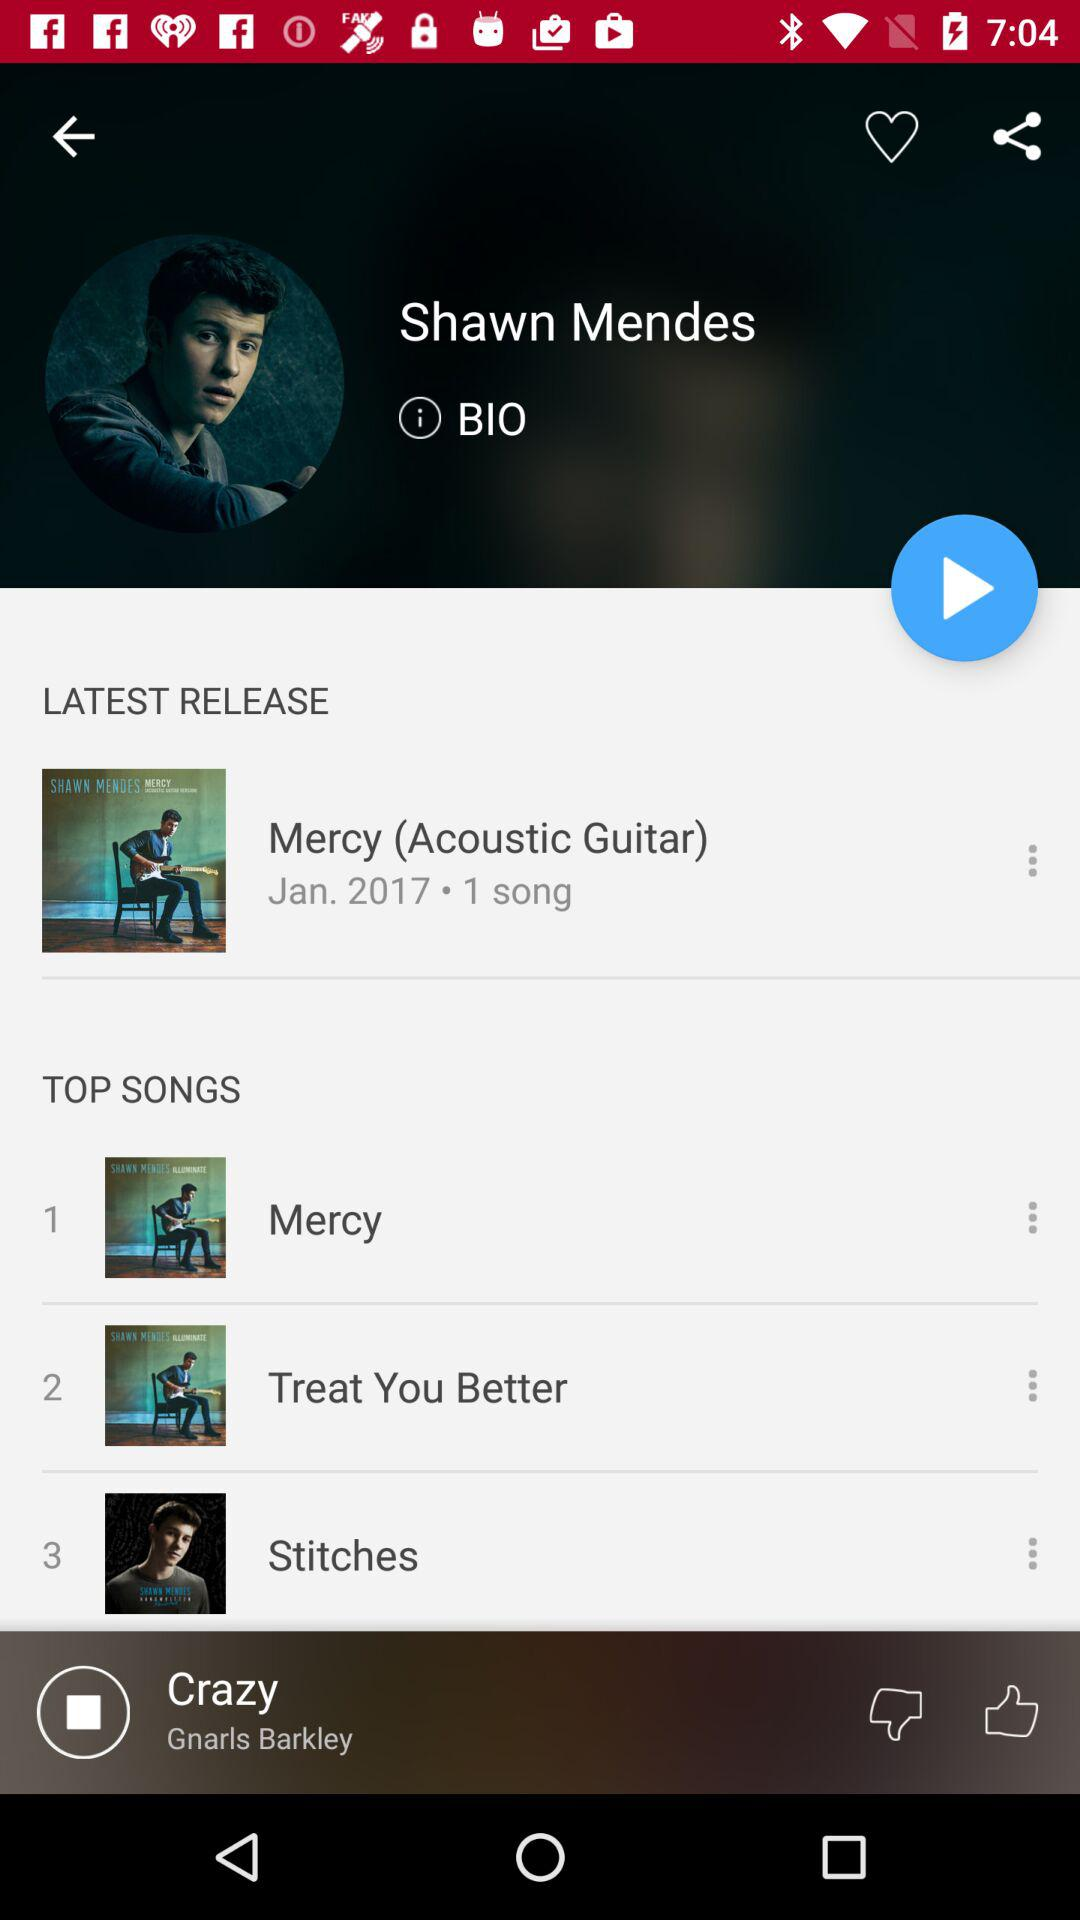How many songs are in the top songs section?
Answer the question using a single word or phrase. 3 